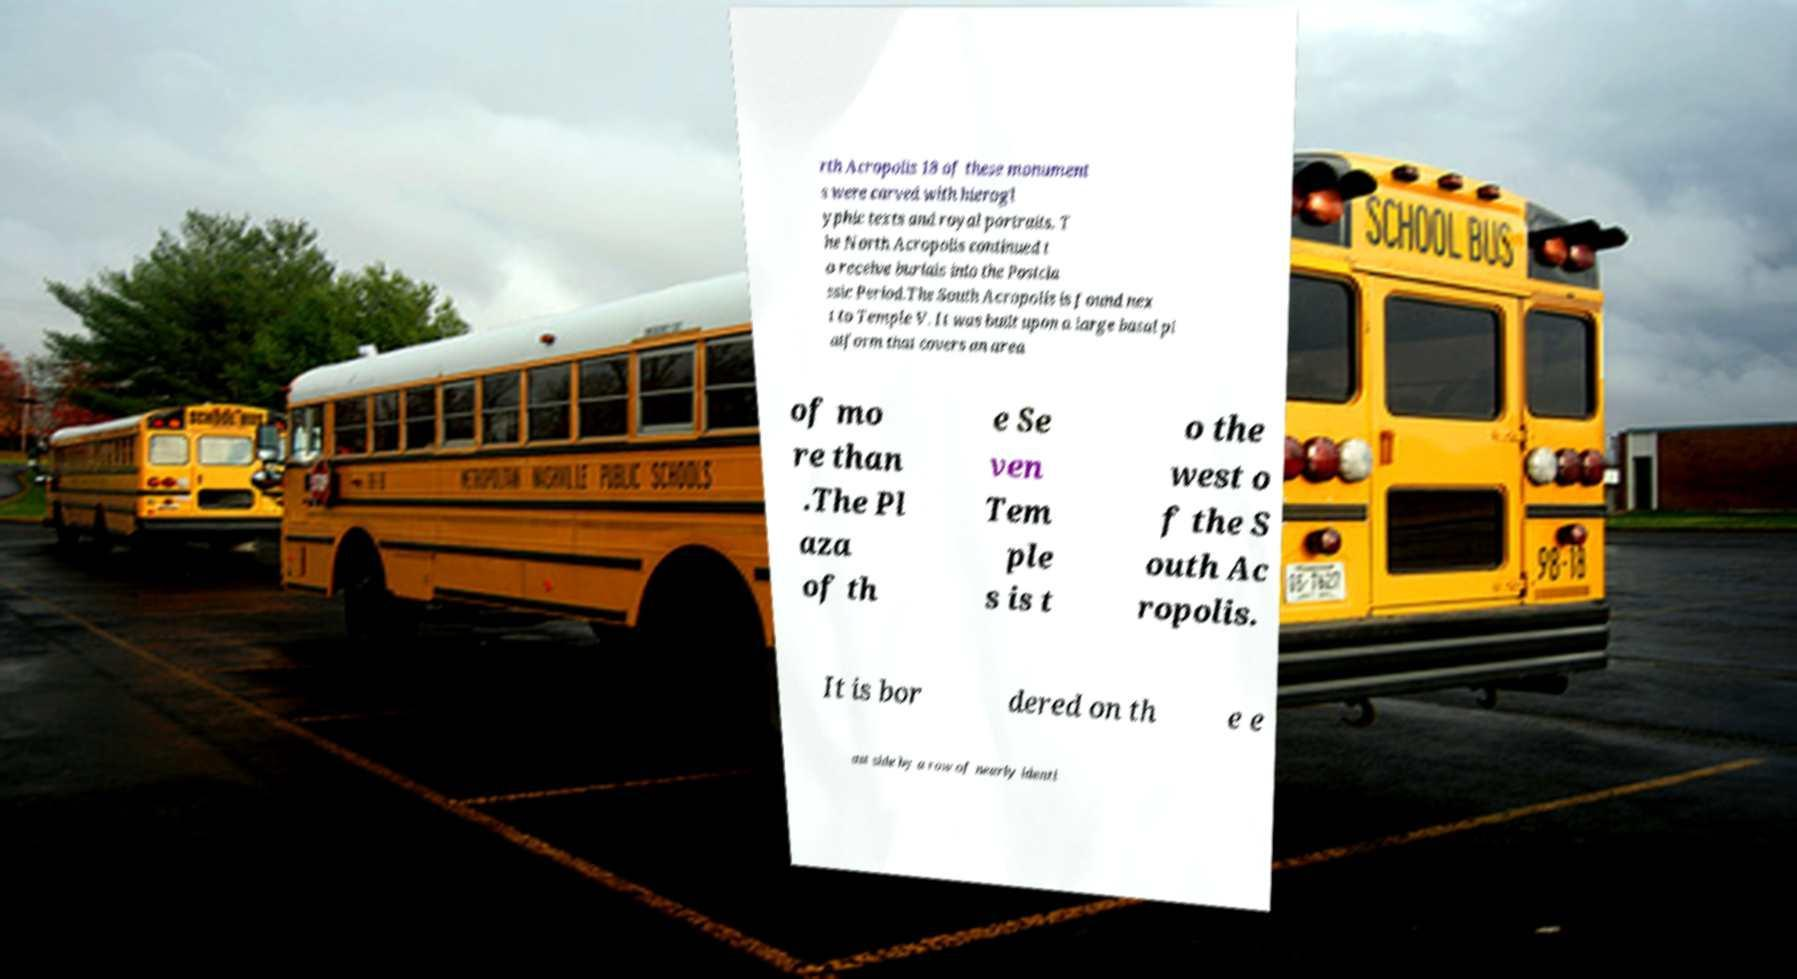What messages or text are displayed in this image? I need them in a readable, typed format. rth Acropolis 18 of these monument s were carved with hierogl yphic texts and royal portraits. T he North Acropolis continued t o receive burials into the Postcla ssic Period.The South Acropolis is found nex t to Temple V. It was built upon a large basal pl atform that covers an area of mo re than .The Pl aza of th e Se ven Tem ple s is t o the west o f the S outh Ac ropolis. It is bor dered on th e e ast side by a row of nearly identi 